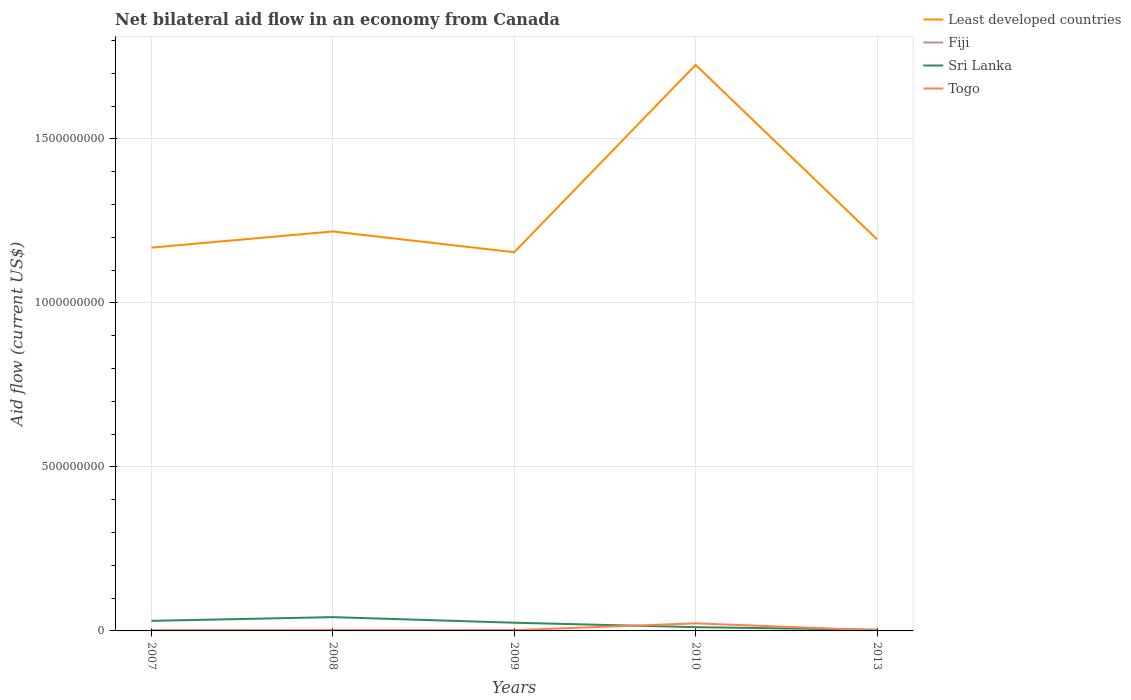How many different coloured lines are there?
Provide a short and direct response. 4. Is the number of lines equal to the number of legend labels?
Your answer should be compact. Yes. Across all years, what is the maximum net bilateral aid flow in Togo?
Your answer should be very brief. 1.90e+06. What is the difference between the highest and the second highest net bilateral aid flow in Least developed countries?
Keep it short and to the point. 5.71e+08. Is the net bilateral aid flow in Fiji strictly greater than the net bilateral aid flow in Least developed countries over the years?
Keep it short and to the point. Yes. How many years are there in the graph?
Keep it short and to the point. 5. What is the difference between two consecutive major ticks on the Y-axis?
Your answer should be compact. 5.00e+08. Does the graph contain any zero values?
Provide a succinct answer. No. Where does the legend appear in the graph?
Provide a short and direct response. Top right. What is the title of the graph?
Offer a very short reply. Net bilateral aid flow in an economy from Canada. What is the label or title of the Y-axis?
Make the answer very short. Aid flow (current US$). What is the Aid flow (current US$) in Least developed countries in 2007?
Keep it short and to the point. 1.17e+09. What is the Aid flow (current US$) in Fiji in 2007?
Provide a succinct answer. 5.00e+05. What is the Aid flow (current US$) of Sri Lanka in 2007?
Ensure brevity in your answer.  3.07e+07. What is the Aid flow (current US$) in Togo in 2007?
Your answer should be very brief. 2.32e+06. What is the Aid flow (current US$) in Least developed countries in 2008?
Your response must be concise. 1.22e+09. What is the Aid flow (current US$) in Sri Lanka in 2008?
Ensure brevity in your answer.  4.20e+07. What is the Aid flow (current US$) in Togo in 2008?
Provide a succinct answer. 2.61e+06. What is the Aid flow (current US$) in Least developed countries in 2009?
Offer a terse response. 1.15e+09. What is the Aid flow (current US$) of Sri Lanka in 2009?
Keep it short and to the point. 2.50e+07. What is the Aid flow (current US$) of Togo in 2009?
Offer a terse response. 2.50e+06. What is the Aid flow (current US$) in Least developed countries in 2010?
Offer a terse response. 1.73e+09. What is the Aid flow (current US$) in Sri Lanka in 2010?
Make the answer very short. 1.15e+07. What is the Aid flow (current US$) of Togo in 2010?
Your answer should be very brief. 2.30e+07. What is the Aid flow (current US$) in Least developed countries in 2013?
Your answer should be compact. 1.19e+09. What is the Aid flow (current US$) of Sri Lanka in 2013?
Give a very brief answer. 3.62e+06. What is the Aid flow (current US$) of Togo in 2013?
Make the answer very short. 1.90e+06. Across all years, what is the maximum Aid flow (current US$) in Least developed countries?
Offer a very short reply. 1.73e+09. Across all years, what is the maximum Aid flow (current US$) of Fiji?
Make the answer very short. 5.00e+05. Across all years, what is the maximum Aid flow (current US$) of Sri Lanka?
Keep it short and to the point. 4.20e+07. Across all years, what is the maximum Aid flow (current US$) of Togo?
Make the answer very short. 2.30e+07. Across all years, what is the minimum Aid flow (current US$) of Least developed countries?
Your response must be concise. 1.15e+09. Across all years, what is the minimum Aid flow (current US$) in Sri Lanka?
Provide a succinct answer. 3.62e+06. Across all years, what is the minimum Aid flow (current US$) in Togo?
Your answer should be compact. 1.90e+06. What is the total Aid flow (current US$) in Least developed countries in the graph?
Provide a short and direct response. 6.46e+09. What is the total Aid flow (current US$) of Fiji in the graph?
Offer a terse response. 1.36e+06. What is the total Aid flow (current US$) of Sri Lanka in the graph?
Offer a terse response. 1.13e+08. What is the total Aid flow (current US$) in Togo in the graph?
Make the answer very short. 3.24e+07. What is the difference between the Aid flow (current US$) in Least developed countries in 2007 and that in 2008?
Offer a terse response. -4.93e+07. What is the difference between the Aid flow (current US$) in Fiji in 2007 and that in 2008?
Keep it short and to the point. 3.00e+04. What is the difference between the Aid flow (current US$) of Sri Lanka in 2007 and that in 2008?
Your response must be concise. -1.13e+07. What is the difference between the Aid flow (current US$) of Togo in 2007 and that in 2008?
Keep it short and to the point. -2.90e+05. What is the difference between the Aid flow (current US$) of Least developed countries in 2007 and that in 2009?
Offer a terse response. 1.41e+07. What is the difference between the Aid flow (current US$) in Sri Lanka in 2007 and that in 2009?
Keep it short and to the point. 5.73e+06. What is the difference between the Aid flow (current US$) in Togo in 2007 and that in 2009?
Offer a very short reply. -1.80e+05. What is the difference between the Aid flow (current US$) in Least developed countries in 2007 and that in 2010?
Your answer should be compact. -5.57e+08. What is the difference between the Aid flow (current US$) in Sri Lanka in 2007 and that in 2010?
Your answer should be compact. 1.93e+07. What is the difference between the Aid flow (current US$) of Togo in 2007 and that in 2010?
Your answer should be compact. -2.07e+07. What is the difference between the Aid flow (current US$) of Least developed countries in 2007 and that in 2013?
Offer a terse response. -2.54e+07. What is the difference between the Aid flow (current US$) in Fiji in 2007 and that in 2013?
Provide a short and direct response. 3.20e+05. What is the difference between the Aid flow (current US$) in Sri Lanka in 2007 and that in 2013?
Keep it short and to the point. 2.71e+07. What is the difference between the Aid flow (current US$) of Togo in 2007 and that in 2013?
Provide a succinct answer. 4.20e+05. What is the difference between the Aid flow (current US$) of Least developed countries in 2008 and that in 2009?
Your answer should be very brief. 6.34e+07. What is the difference between the Aid flow (current US$) of Fiji in 2008 and that in 2009?
Provide a short and direct response. 3.40e+05. What is the difference between the Aid flow (current US$) in Sri Lanka in 2008 and that in 2009?
Offer a very short reply. 1.70e+07. What is the difference between the Aid flow (current US$) in Least developed countries in 2008 and that in 2010?
Keep it short and to the point. -5.08e+08. What is the difference between the Aid flow (current US$) in Sri Lanka in 2008 and that in 2010?
Give a very brief answer. 3.06e+07. What is the difference between the Aid flow (current US$) of Togo in 2008 and that in 2010?
Provide a succinct answer. -2.04e+07. What is the difference between the Aid flow (current US$) of Least developed countries in 2008 and that in 2013?
Provide a short and direct response. 2.38e+07. What is the difference between the Aid flow (current US$) in Sri Lanka in 2008 and that in 2013?
Offer a terse response. 3.84e+07. What is the difference between the Aid flow (current US$) in Togo in 2008 and that in 2013?
Offer a very short reply. 7.10e+05. What is the difference between the Aid flow (current US$) in Least developed countries in 2009 and that in 2010?
Your answer should be compact. -5.71e+08. What is the difference between the Aid flow (current US$) of Sri Lanka in 2009 and that in 2010?
Offer a terse response. 1.35e+07. What is the difference between the Aid flow (current US$) in Togo in 2009 and that in 2010?
Ensure brevity in your answer.  -2.06e+07. What is the difference between the Aid flow (current US$) of Least developed countries in 2009 and that in 2013?
Keep it short and to the point. -3.96e+07. What is the difference between the Aid flow (current US$) of Sri Lanka in 2009 and that in 2013?
Offer a very short reply. 2.14e+07. What is the difference between the Aid flow (current US$) of Least developed countries in 2010 and that in 2013?
Provide a succinct answer. 5.32e+08. What is the difference between the Aid flow (current US$) of Sri Lanka in 2010 and that in 2013?
Offer a very short reply. 7.85e+06. What is the difference between the Aid flow (current US$) in Togo in 2010 and that in 2013?
Give a very brief answer. 2.12e+07. What is the difference between the Aid flow (current US$) in Least developed countries in 2007 and the Aid flow (current US$) in Fiji in 2008?
Make the answer very short. 1.17e+09. What is the difference between the Aid flow (current US$) in Least developed countries in 2007 and the Aid flow (current US$) in Sri Lanka in 2008?
Offer a very short reply. 1.13e+09. What is the difference between the Aid flow (current US$) in Least developed countries in 2007 and the Aid flow (current US$) in Togo in 2008?
Offer a very short reply. 1.17e+09. What is the difference between the Aid flow (current US$) in Fiji in 2007 and the Aid flow (current US$) in Sri Lanka in 2008?
Your answer should be very brief. -4.16e+07. What is the difference between the Aid flow (current US$) of Fiji in 2007 and the Aid flow (current US$) of Togo in 2008?
Ensure brevity in your answer.  -2.11e+06. What is the difference between the Aid flow (current US$) of Sri Lanka in 2007 and the Aid flow (current US$) of Togo in 2008?
Offer a very short reply. 2.81e+07. What is the difference between the Aid flow (current US$) of Least developed countries in 2007 and the Aid flow (current US$) of Fiji in 2009?
Your response must be concise. 1.17e+09. What is the difference between the Aid flow (current US$) in Least developed countries in 2007 and the Aid flow (current US$) in Sri Lanka in 2009?
Make the answer very short. 1.14e+09. What is the difference between the Aid flow (current US$) in Least developed countries in 2007 and the Aid flow (current US$) in Togo in 2009?
Your answer should be very brief. 1.17e+09. What is the difference between the Aid flow (current US$) of Fiji in 2007 and the Aid flow (current US$) of Sri Lanka in 2009?
Keep it short and to the point. -2.45e+07. What is the difference between the Aid flow (current US$) of Sri Lanka in 2007 and the Aid flow (current US$) of Togo in 2009?
Offer a very short reply. 2.82e+07. What is the difference between the Aid flow (current US$) in Least developed countries in 2007 and the Aid flow (current US$) in Fiji in 2010?
Offer a terse response. 1.17e+09. What is the difference between the Aid flow (current US$) in Least developed countries in 2007 and the Aid flow (current US$) in Sri Lanka in 2010?
Make the answer very short. 1.16e+09. What is the difference between the Aid flow (current US$) of Least developed countries in 2007 and the Aid flow (current US$) of Togo in 2010?
Your response must be concise. 1.15e+09. What is the difference between the Aid flow (current US$) of Fiji in 2007 and the Aid flow (current US$) of Sri Lanka in 2010?
Ensure brevity in your answer.  -1.10e+07. What is the difference between the Aid flow (current US$) in Fiji in 2007 and the Aid flow (current US$) in Togo in 2010?
Offer a terse response. -2.26e+07. What is the difference between the Aid flow (current US$) of Sri Lanka in 2007 and the Aid flow (current US$) of Togo in 2010?
Your response must be concise. 7.68e+06. What is the difference between the Aid flow (current US$) of Least developed countries in 2007 and the Aid flow (current US$) of Fiji in 2013?
Your answer should be compact. 1.17e+09. What is the difference between the Aid flow (current US$) in Least developed countries in 2007 and the Aid flow (current US$) in Sri Lanka in 2013?
Your answer should be compact. 1.17e+09. What is the difference between the Aid flow (current US$) in Least developed countries in 2007 and the Aid flow (current US$) in Togo in 2013?
Ensure brevity in your answer.  1.17e+09. What is the difference between the Aid flow (current US$) of Fiji in 2007 and the Aid flow (current US$) of Sri Lanka in 2013?
Your answer should be very brief. -3.12e+06. What is the difference between the Aid flow (current US$) in Fiji in 2007 and the Aid flow (current US$) in Togo in 2013?
Provide a succinct answer. -1.40e+06. What is the difference between the Aid flow (current US$) in Sri Lanka in 2007 and the Aid flow (current US$) in Togo in 2013?
Your answer should be very brief. 2.88e+07. What is the difference between the Aid flow (current US$) of Least developed countries in 2008 and the Aid flow (current US$) of Fiji in 2009?
Make the answer very short. 1.22e+09. What is the difference between the Aid flow (current US$) in Least developed countries in 2008 and the Aid flow (current US$) in Sri Lanka in 2009?
Offer a very short reply. 1.19e+09. What is the difference between the Aid flow (current US$) in Least developed countries in 2008 and the Aid flow (current US$) in Togo in 2009?
Offer a terse response. 1.22e+09. What is the difference between the Aid flow (current US$) of Fiji in 2008 and the Aid flow (current US$) of Sri Lanka in 2009?
Provide a succinct answer. -2.45e+07. What is the difference between the Aid flow (current US$) in Fiji in 2008 and the Aid flow (current US$) in Togo in 2009?
Your response must be concise. -2.03e+06. What is the difference between the Aid flow (current US$) in Sri Lanka in 2008 and the Aid flow (current US$) in Togo in 2009?
Make the answer very short. 3.96e+07. What is the difference between the Aid flow (current US$) of Least developed countries in 2008 and the Aid flow (current US$) of Fiji in 2010?
Provide a short and direct response. 1.22e+09. What is the difference between the Aid flow (current US$) in Least developed countries in 2008 and the Aid flow (current US$) in Sri Lanka in 2010?
Give a very brief answer. 1.21e+09. What is the difference between the Aid flow (current US$) of Least developed countries in 2008 and the Aid flow (current US$) of Togo in 2010?
Offer a terse response. 1.19e+09. What is the difference between the Aid flow (current US$) in Fiji in 2008 and the Aid flow (current US$) in Sri Lanka in 2010?
Provide a short and direct response. -1.10e+07. What is the difference between the Aid flow (current US$) in Fiji in 2008 and the Aid flow (current US$) in Togo in 2010?
Make the answer very short. -2.26e+07. What is the difference between the Aid flow (current US$) of Sri Lanka in 2008 and the Aid flow (current US$) of Togo in 2010?
Provide a short and direct response. 1.90e+07. What is the difference between the Aid flow (current US$) of Least developed countries in 2008 and the Aid flow (current US$) of Fiji in 2013?
Offer a terse response. 1.22e+09. What is the difference between the Aid flow (current US$) in Least developed countries in 2008 and the Aid flow (current US$) in Sri Lanka in 2013?
Give a very brief answer. 1.21e+09. What is the difference between the Aid flow (current US$) in Least developed countries in 2008 and the Aid flow (current US$) in Togo in 2013?
Offer a very short reply. 1.22e+09. What is the difference between the Aid flow (current US$) in Fiji in 2008 and the Aid flow (current US$) in Sri Lanka in 2013?
Ensure brevity in your answer.  -3.15e+06. What is the difference between the Aid flow (current US$) in Fiji in 2008 and the Aid flow (current US$) in Togo in 2013?
Offer a terse response. -1.43e+06. What is the difference between the Aid flow (current US$) of Sri Lanka in 2008 and the Aid flow (current US$) of Togo in 2013?
Your answer should be compact. 4.02e+07. What is the difference between the Aid flow (current US$) of Least developed countries in 2009 and the Aid flow (current US$) of Fiji in 2010?
Provide a short and direct response. 1.15e+09. What is the difference between the Aid flow (current US$) of Least developed countries in 2009 and the Aid flow (current US$) of Sri Lanka in 2010?
Offer a terse response. 1.14e+09. What is the difference between the Aid flow (current US$) of Least developed countries in 2009 and the Aid flow (current US$) of Togo in 2010?
Offer a very short reply. 1.13e+09. What is the difference between the Aid flow (current US$) of Fiji in 2009 and the Aid flow (current US$) of Sri Lanka in 2010?
Keep it short and to the point. -1.13e+07. What is the difference between the Aid flow (current US$) of Fiji in 2009 and the Aid flow (current US$) of Togo in 2010?
Offer a very short reply. -2.29e+07. What is the difference between the Aid flow (current US$) of Sri Lanka in 2009 and the Aid flow (current US$) of Togo in 2010?
Provide a short and direct response. 1.95e+06. What is the difference between the Aid flow (current US$) of Least developed countries in 2009 and the Aid flow (current US$) of Fiji in 2013?
Ensure brevity in your answer.  1.15e+09. What is the difference between the Aid flow (current US$) in Least developed countries in 2009 and the Aid flow (current US$) in Sri Lanka in 2013?
Keep it short and to the point. 1.15e+09. What is the difference between the Aid flow (current US$) in Least developed countries in 2009 and the Aid flow (current US$) in Togo in 2013?
Your response must be concise. 1.15e+09. What is the difference between the Aid flow (current US$) in Fiji in 2009 and the Aid flow (current US$) in Sri Lanka in 2013?
Keep it short and to the point. -3.49e+06. What is the difference between the Aid flow (current US$) of Fiji in 2009 and the Aid flow (current US$) of Togo in 2013?
Give a very brief answer. -1.77e+06. What is the difference between the Aid flow (current US$) of Sri Lanka in 2009 and the Aid flow (current US$) of Togo in 2013?
Offer a terse response. 2.31e+07. What is the difference between the Aid flow (current US$) of Least developed countries in 2010 and the Aid flow (current US$) of Fiji in 2013?
Keep it short and to the point. 1.73e+09. What is the difference between the Aid flow (current US$) in Least developed countries in 2010 and the Aid flow (current US$) in Sri Lanka in 2013?
Your response must be concise. 1.72e+09. What is the difference between the Aid flow (current US$) in Least developed countries in 2010 and the Aid flow (current US$) in Togo in 2013?
Give a very brief answer. 1.72e+09. What is the difference between the Aid flow (current US$) in Fiji in 2010 and the Aid flow (current US$) in Sri Lanka in 2013?
Your answer should be compact. -3.54e+06. What is the difference between the Aid flow (current US$) of Fiji in 2010 and the Aid flow (current US$) of Togo in 2013?
Your answer should be very brief. -1.82e+06. What is the difference between the Aid flow (current US$) of Sri Lanka in 2010 and the Aid flow (current US$) of Togo in 2013?
Provide a short and direct response. 9.57e+06. What is the average Aid flow (current US$) of Least developed countries per year?
Provide a short and direct response. 1.29e+09. What is the average Aid flow (current US$) of Fiji per year?
Your answer should be compact. 2.72e+05. What is the average Aid flow (current US$) in Sri Lanka per year?
Provide a succinct answer. 2.26e+07. What is the average Aid flow (current US$) in Togo per year?
Give a very brief answer. 6.48e+06. In the year 2007, what is the difference between the Aid flow (current US$) of Least developed countries and Aid flow (current US$) of Fiji?
Ensure brevity in your answer.  1.17e+09. In the year 2007, what is the difference between the Aid flow (current US$) in Least developed countries and Aid flow (current US$) in Sri Lanka?
Your response must be concise. 1.14e+09. In the year 2007, what is the difference between the Aid flow (current US$) of Least developed countries and Aid flow (current US$) of Togo?
Ensure brevity in your answer.  1.17e+09. In the year 2007, what is the difference between the Aid flow (current US$) of Fiji and Aid flow (current US$) of Sri Lanka?
Provide a short and direct response. -3.02e+07. In the year 2007, what is the difference between the Aid flow (current US$) in Fiji and Aid flow (current US$) in Togo?
Ensure brevity in your answer.  -1.82e+06. In the year 2007, what is the difference between the Aid flow (current US$) in Sri Lanka and Aid flow (current US$) in Togo?
Offer a terse response. 2.84e+07. In the year 2008, what is the difference between the Aid flow (current US$) of Least developed countries and Aid flow (current US$) of Fiji?
Keep it short and to the point. 1.22e+09. In the year 2008, what is the difference between the Aid flow (current US$) of Least developed countries and Aid flow (current US$) of Sri Lanka?
Make the answer very short. 1.18e+09. In the year 2008, what is the difference between the Aid flow (current US$) in Least developed countries and Aid flow (current US$) in Togo?
Offer a terse response. 1.22e+09. In the year 2008, what is the difference between the Aid flow (current US$) in Fiji and Aid flow (current US$) in Sri Lanka?
Make the answer very short. -4.16e+07. In the year 2008, what is the difference between the Aid flow (current US$) of Fiji and Aid flow (current US$) of Togo?
Your answer should be very brief. -2.14e+06. In the year 2008, what is the difference between the Aid flow (current US$) of Sri Lanka and Aid flow (current US$) of Togo?
Offer a terse response. 3.94e+07. In the year 2009, what is the difference between the Aid flow (current US$) in Least developed countries and Aid flow (current US$) in Fiji?
Offer a very short reply. 1.15e+09. In the year 2009, what is the difference between the Aid flow (current US$) in Least developed countries and Aid flow (current US$) in Sri Lanka?
Give a very brief answer. 1.13e+09. In the year 2009, what is the difference between the Aid flow (current US$) in Least developed countries and Aid flow (current US$) in Togo?
Offer a very short reply. 1.15e+09. In the year 2009, what is the difference between the Aid flow (current US$) in Fiji and Aid flow (current US$) in Sri Lanka?
Give a very brief answer. -2.49e+07. In the year 2009, what is the difference between the Aid flow (current US$) in Fiji and Aid flow (current US$) in Togo?
Offer a terse response. -2.37e+06. In the year 2009, what is the difference between the Aid flow (current US$) in Sri Lanka and Aid flow (current US$) in Togo?
Keep it short and to the point. 2.25e+07. In the year 2010, what is the difference between the Aid flow (current US$) in Least developed countries and Aid flow (current US$) in Fiji?
Give a very brief answer. 1.73e+09. In the year 2010, what is the difference between the Aid flow (current US$) in Least developed countries and Aid flow (current US$) in Sri Lanka?
Offer a very short reply. 1.71e+09. In the year 2010, what is the difference between the Aid flow (current US$) of Least developed countries and Aid flow (current US$) of Togo?
Offer a very short reply. 1.70e+09. In the year 2010, what is the difference between the Aid flow (current US$) in Fiji and Aid flow (current US$) in Sri Lanka?
Keep it short and to the point. -1.14e+07. In the year 2010, what is the difference between the Aid flow (current US$) of Fiji and Aid flow (current US$) of Togo?
Provide a succinct answer. -2.30e+07. In the year 2010, what is the difference between the Aid flow (current US$) of Sri Lanka and Aid flow (current US$) of Togo?
Provide a short and direct response. -1.16e+07. In the year 2013, what is the difference between the Aid flow (current US$) in Least developed countries and Aid flow (current US$) in Fiji?
Your answer should be compact. 1.19e+09. In the year 2013, what is the difference between the Aid flow (current US$) in Least developed countries and Aid flow (current US$) in Sri Lanka?
Provide a short and direct response. 1.19e+09. In the year 2013, what is the difference between the Aid flow (current US$) of Least developed countries and Aid flow (current US$) of Togo?
Your response must be concise. 1.19e+09. In the year 2013, what is the difference between the Aid flow (current US$) in Fiji and Aid flow (current US$) in Sri Lanka?
Provide a short and direct response. -3.44e+06. In the year 2013, what is the difference between the Aid flow (current US$) of Fiji and Aid flow (current US$) of Togo?
Keep it short and to the point. -1.72e+06. In the year 2013, what is the difference between the Aid flow (current US$) in Sri Lanka and Aid flow (current US$) in Togo?
Provide a succinct answer. 1.72e+06. What is the ratio of the Aid flow (current US$) in Least developed countries in 2007 to that in 2008?
Offer a terse response. 0.96. What is the ratio of the Aid flow (current US$) in Fiji in 2007 to that in 2008?
Your answer should be compact. 1.06. What is the ratio of the Aid flow (current US$) of Sri Lanka in 2007 to that in 2008?
Give a very brief answer. 0.73. What is the ratio of the Aid flow (current US$) in Least developed countries in 2007 to that in 2009?
Keep it short and to the point. 1.01. What is the ratio of the Aid flow (current US$) of Fiji in 2007 to that in 2009?
Your answer should be very brief. 3.85. What is the ratio of the Aid flow (current US$) of Sri Lanka in 2007 to that in 2009?
Provide a succinct answer. 1.23. What is the ratio of the Aid flow (current US$) in Togo in 2007 to that in 2009?
Your response must be concise. 0.93. What is the ratio of the Aid flow (current US$) of Least developed countries in 2007 to that in 2010?
Make the answer very short. 0.68. What is the ratio of the Aid flow (current US$) of Fiji in 2007 to that in 2010?
Make the answer very short. 6.25. What is the ratio of the Aid flow (current US$) of Sri Lanka in 2007 to that in 2010?
Ensure brevity in your answer.  2.68. What is the ratio of the Aid flow (current US$) in Togo in 2007 to that in 2010?
Offer a very short reply. 0.1. What is the ratio of the Aid flow (current US$) in Least developed countries in 2007 to that in 2013?
Give a very brief answer. 0.98. What is the ratio of the Aid flow (current US$) in Fiji in 2007 to that in 2013?
Your answer should be compact. 2.78. What is the ratio of the Aid flow (current US$) of Sri Lanka in 2007 to that in 2013?
Offer a very short reply. 8.49. What is the ratio of the Aid flow (current US$) of Togo in 2007 to that in 2013?
Offer a very short reply. 1.22. What is the ratio of the Aid flow (current US$) of Least developed countries in 2008 to that in 2009?
Ensure brevity in your answer.  1.05. What is the ratio of the Aid flow (current US$) of Fiji in 2008 to that in 2009?
Provide a short and direct response. 3.62. What is the ratio of the Aid flow (current US$) of Sri Lanka in 2008 to that in 2009?
Your answer should be compact. 1.68. What is the ratio of the Aid flow (current US$) in Togo in 2008 to that in 2009?
Your response must be concise. 1.04. What is the ratio of the Aid flow (current US$) of Least developed countries in 2008 to that in 2010?
Your response must be concise. 0.71. What is the ratio of the Aid flow (current US$) in Fiji in 2008 to that in 2010?
Keep it short and to the point. 5.88. What is the ratio of the Aid flow (current US$) in Sri Lanka in 2008 to that in 2010?
Give a very brief answer. 3.67. What is the ratio of the Aid flow (current US$) of Togo in 2008 to that in 2010?
Your answer should be very brief. 0.11. What is the ratio of the Aid flow (current US$) of Least developed countries in 2008 to that in 2013?
Offer a terse response. 1.02. What is the ratio of the Aid flow (current US$) of Fiji in 2008 to that in 2013?
Make the answer very short. 2.61. What is the ratio of the Aid flow (current US$) of Sri Lanka in 2008 to that in 2013?
Keep it short and to the point. 11.62. What is the ratio of the Aid flow (current US$) of Togo in 2008 to that in 2013?
Offer a very short reply. 1.37. What is the ratio of the Aid flow (current US$) in Least developed countries in 2009 to that in 2010?
Provide a short and direct response. 0.67. What is the ratio of the Aid flow (current US$) of Fiji in 2009 to that in 2010?
Ensure brevity in your answer.  1.62. What is the ratio of the Aid flow (current US$) in Sri Lanka in 2009 to that in 2010?
Your answer should be compact. 2.18. What is the ratio of the Aid flow (current US$) in Togo in 2009 to that in 2010?
Provide a succinct answer. 0.11. What is the ratio of the Aid flow (current US$) in Least developed countries in 2009 to that in 2013?
Your answer should be very brief. 0.97. What is the ratio of the Aid flow (current US$) of Fiji in 2009 to that in 2013?
Provide a succinct answer. 0.72. What is the ratio of the Aid flow (current US$) of Sri Lanka in 2009 to that in 2013?
Your answer should be very brief. 6.91. What is the ratio of the Aid flow (current US$) of Togo in 2009 to that in 2013?
Your response must be concise. 1.32. What is the ratio of the Aid flow (current US$) of Least developed countries in 2010 to that in 2013?
Give a very brief answer. 1.45. What is the ratio of the Aid flow (current US$) of Fiji in 2010 to that in 2013?
Offer a terse response. 0.44. What is the ratio of the Aid flow (current US$) of Sri Lanka in 2010 to that in 2013?
Offer a very short reply. 3.17. What is the ratio of the Aid flow (current US$) of Togo in 2010 to that in 2013?
Your answer should be very brief. 12.13. What is the difference between the highest and the second highest Aid flow (current US$) of Least developed countries?
Provide a short and direct response. 5.08e+08. What is the difference between the highest and the second highest Aid flow (current US$) in Sri Lanka?
Offer a very short reply. 1.13e+07. What is the difference between the highest and the second highest Aid flow (current US$) of Togo?
Ensure brevity in your answer.  2.04e+07. What is the difference between the highest and the lowest Aid flow (current US$) of Least developed countries?
Your answer should be very brief. 5.71e+08. What is the difference between the highest and the lowest Aid flow (current US$) in Sri Lanka?
Your answer should be very brief. 3.84e+07. What is the difference between the highest and the lowest Aid flow (current US$) of Togo?
Offer a very short reply. 2.12e+07. 